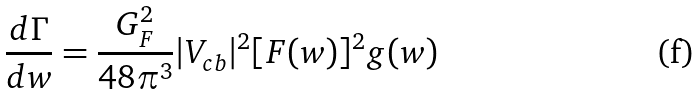Convert formula to latex. <formula><loc_0><loc_0><loc_500><loc_500>\frac { d \Gamma } { d w } = \frac { G _ { F } ^ { 2 } } { 4 8 \pi ^ { 3 } } | V _ { c b } | ^ { 2 } [ F ( w ) ] ^ { 2 } g ( w )</formula> 